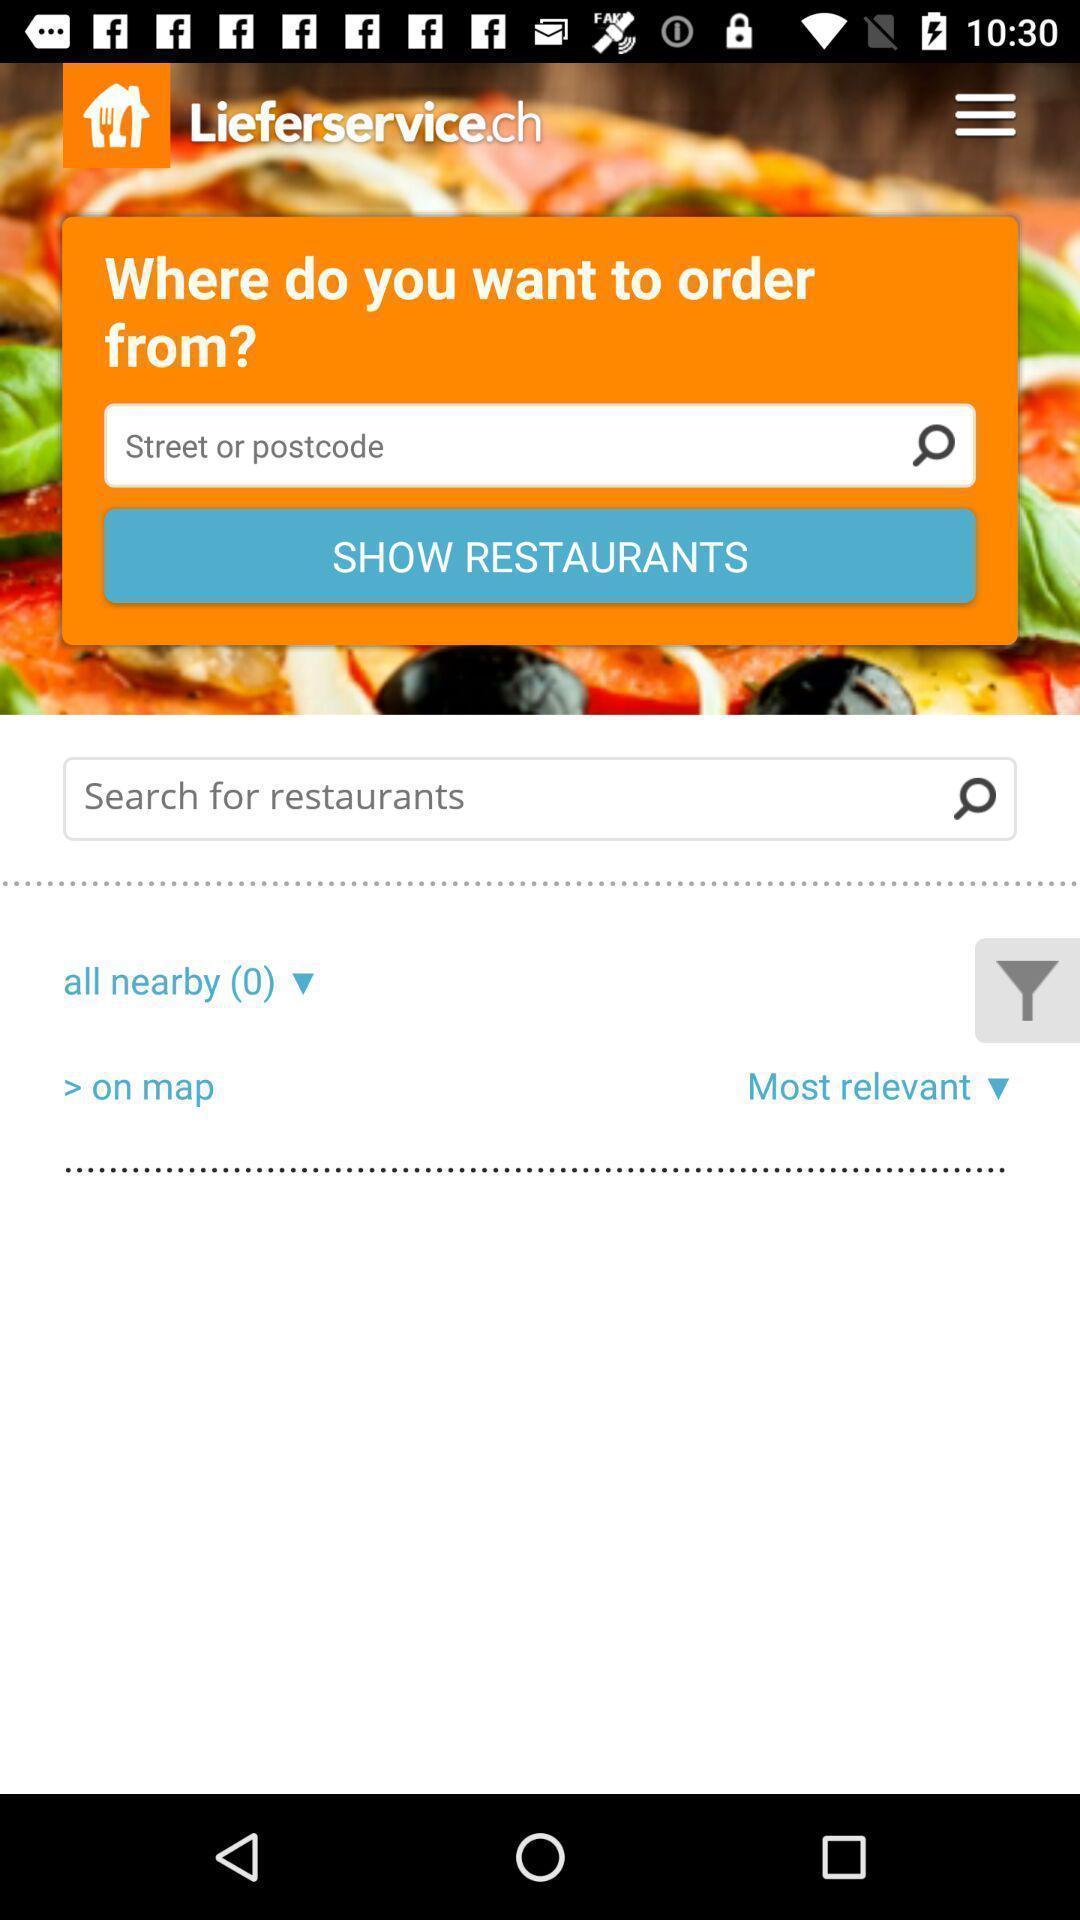Provide a textual representation of this image. Select a restaurant to order. 